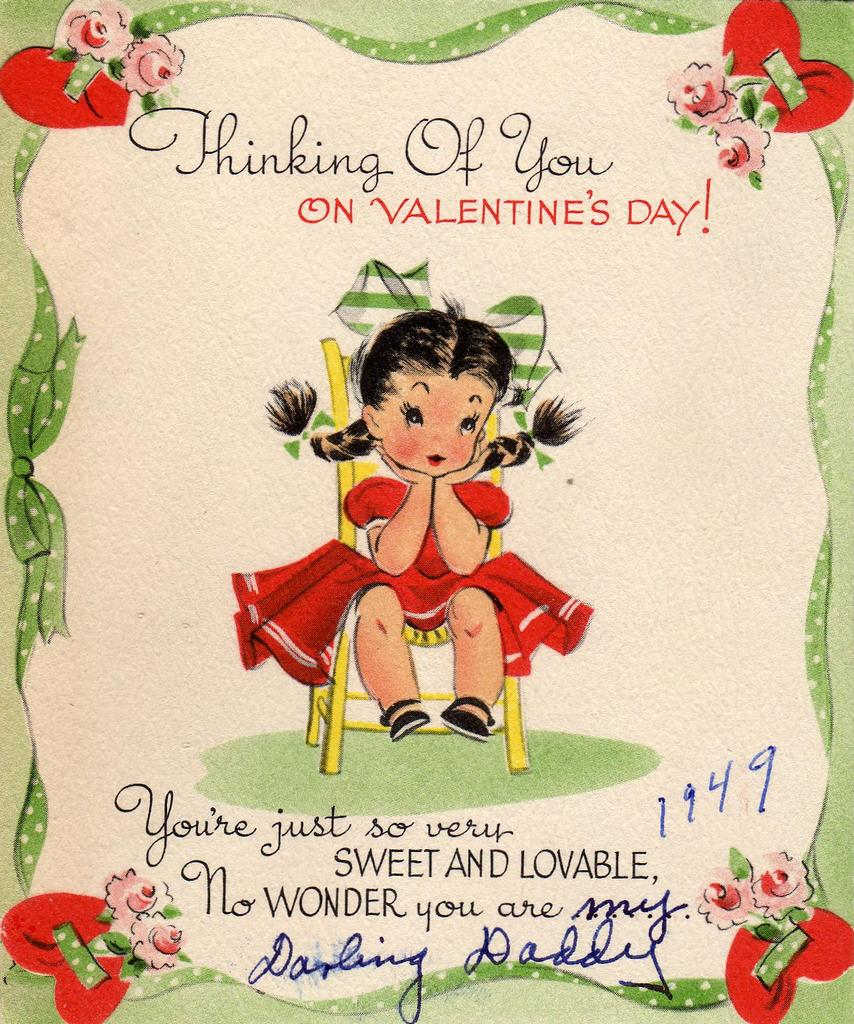What is featured in the image? There is a poster in the image. What can be found on the poster? The poster contains text and depicts a girl. What type of ornament is hanging from the girl's neck in the image? There is no ornament visible around the girl's neck in the image. How does the poster influence the user's impulse to take a trip? The image does not contain any information about trips or impulses, so it cannot influence the user's decision in that regard. 